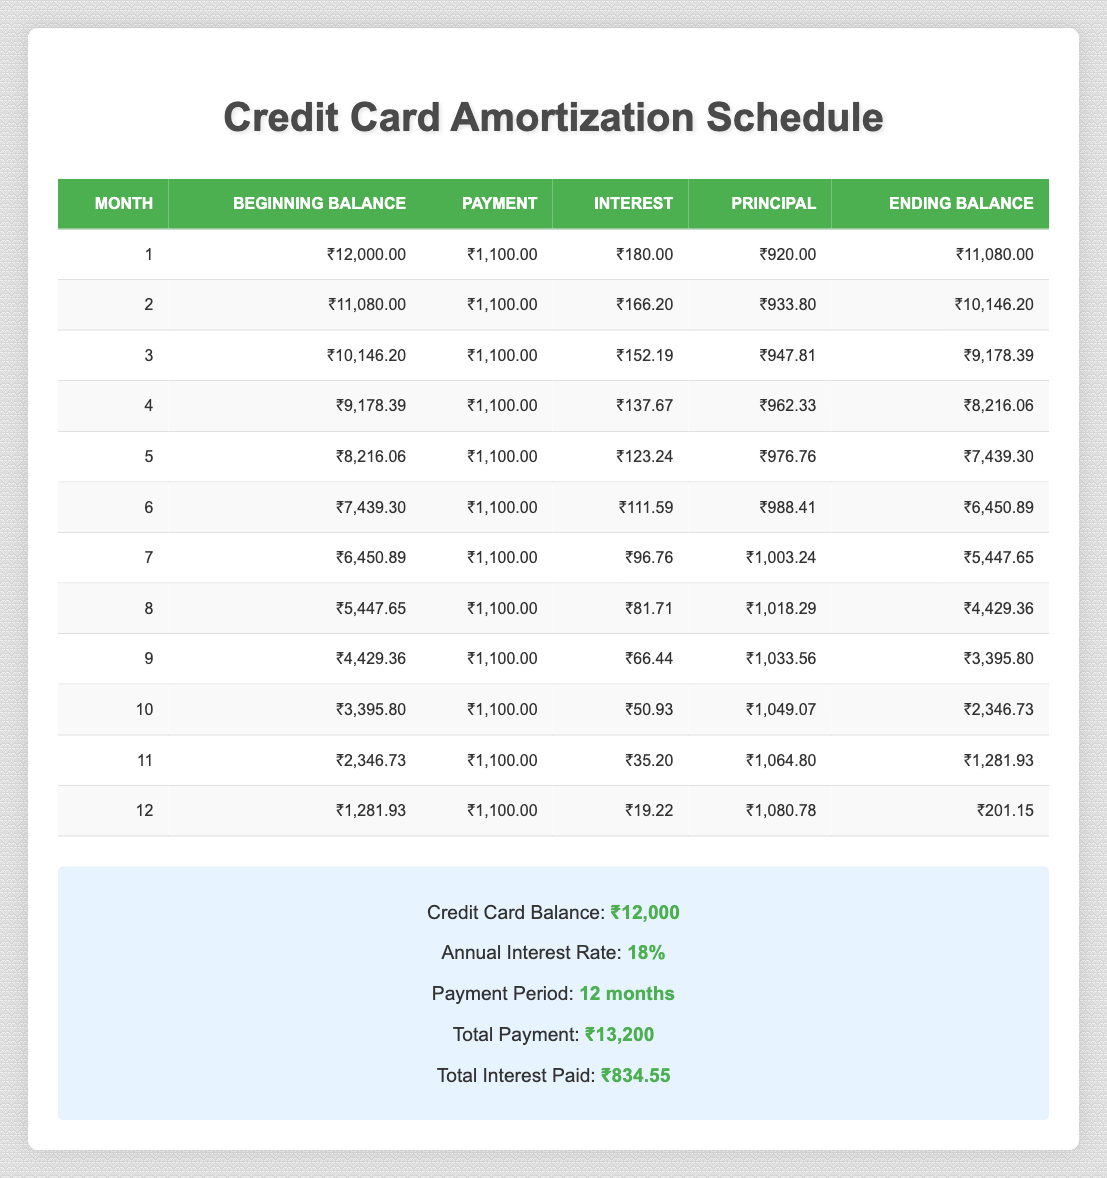What is the total payment made over the 12 months? The total payment is listed in the summary section of the table, where it mentions the total payment as ₹13,200.
Answer: ₹13,200 What was the ending balance after the first month? In the first month's row of the table, the ending balance is listed as ₹11,080.
Answer: ₹11,080 Which month had the highest principal payment? By looking at the principal payments in each month's row, the highest principal payment is in the 12th month, which is ₹1,080.78.
Answer: ₹1,080.78 Is the total interest paid over the 12 months greater than ₹800? The total interest paid is mentioned in the summary section as ₹834.55, which is greater than ₹800.
Answer: Yes What is the difference between the beginning balance in month 1 and month 12? The beginning balance in month 1 is ₹12,000, while the beginning balance in month 12 is ₹1,281.93. The difference is calculated as ₹12,000 - ₹1,281.93 = ₹10,718.07.
Answer: ₹10,718.07 In which month is the ending balance less than ₹5,000? By checking each month's ending balance, the 7th month has an ending balance of ₹5,447.65, and the 8th month has ₹4,429.36, which is less than ₹5,000. Therefore, the 8th month is the first month with an ending balance less than ₹5,000.
Answer: 8 What is the average interest paid per month over the 12 months? The total interest paid is ₹834.55 divided by 12 months. Calculating this gives an average interest of ₹834.55 / 12 = ₹69.54 approximately.
Answer: ₹69.54 How much principal was paid off in the 10th month? In the 10th month's row, the principal payment is recorded as ₹1,049.07.
Answer: ₹1,049.07 Is the payment amount consistent every month? The payment amount in each month's row is listed as ₹1,100, indicating that it remains consistent throughout the payment period.
Answer: Yes 